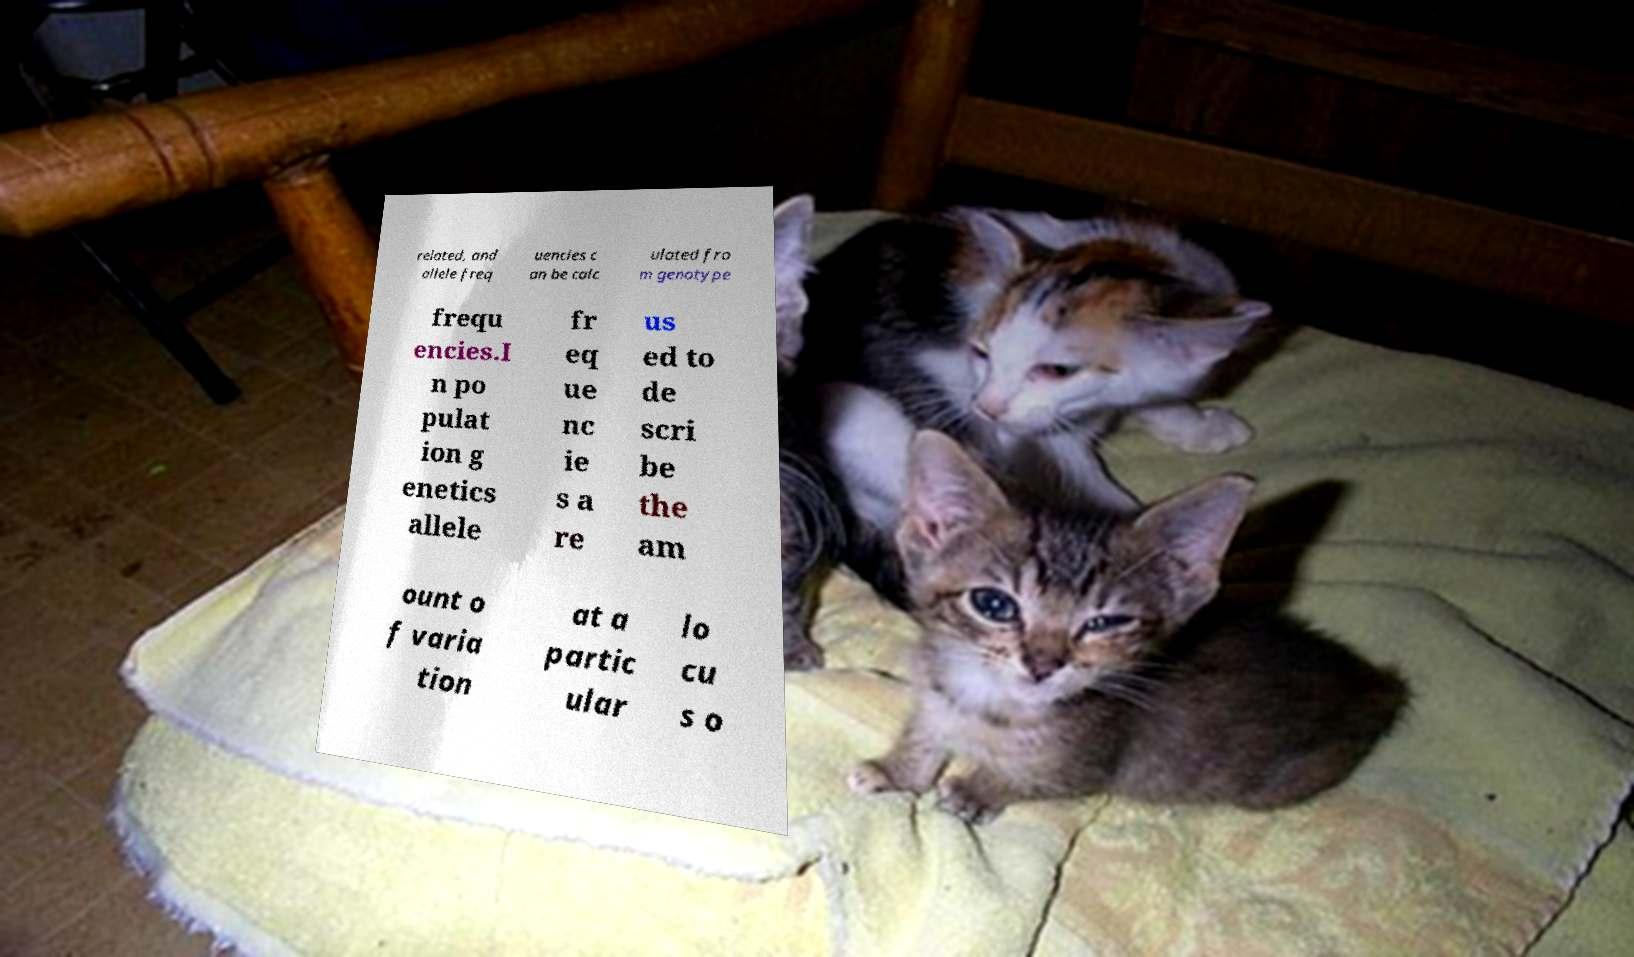Please identify and transcribe the text found in this image. related, and allele freq uencies c an be calc ulated fro m genotype frequ encies.I n po pulat ion g enetics allele fr eq ue nc ie s a re us ed to de scri be the am ount o f varia tion at a partic ular lo cu s o 